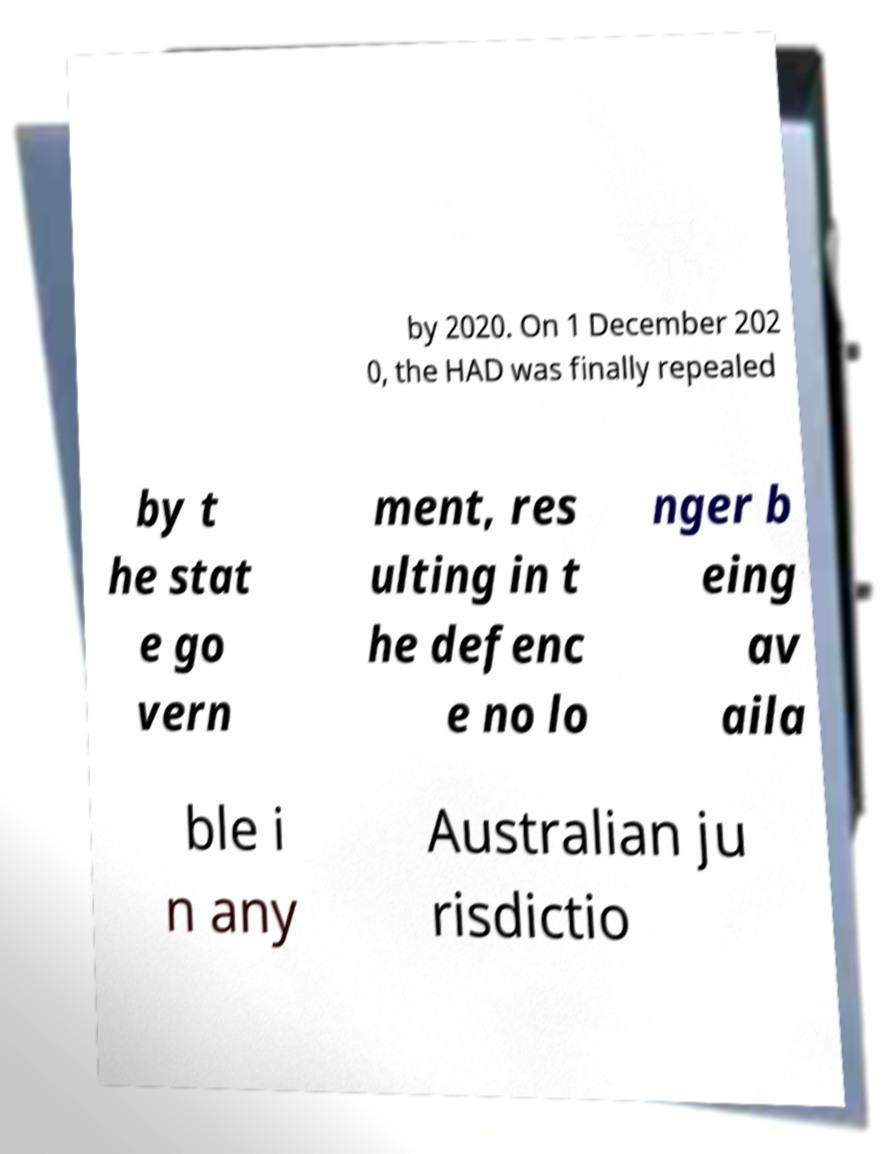Can you accurately transcribe the text from the provided image for me? by 2020. On 1 December 202 0, the HAD was finally repealed by t he stat e go vern ment, res ulting in t he defenc e no lo nger b eing av aila ble i n any Australian ju risdictio 